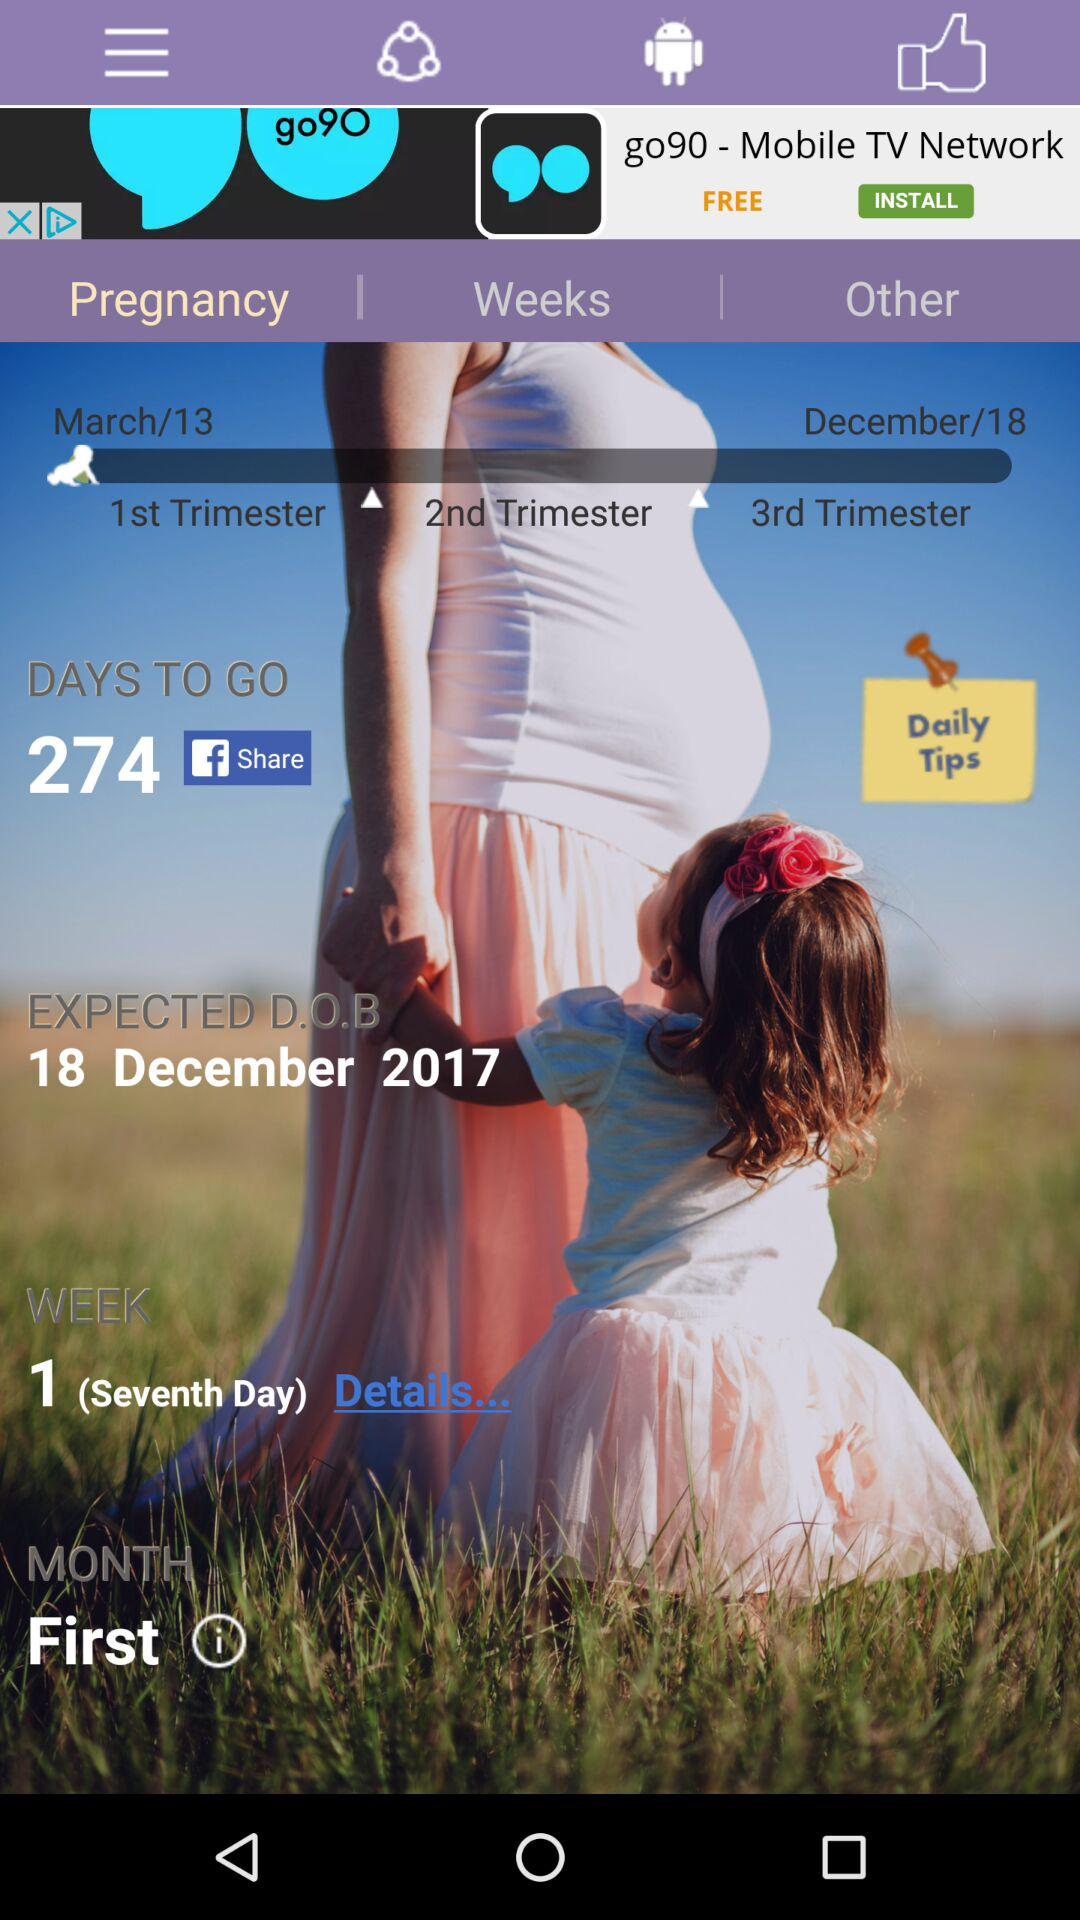What is the shown week number? The shown week number is 1. 